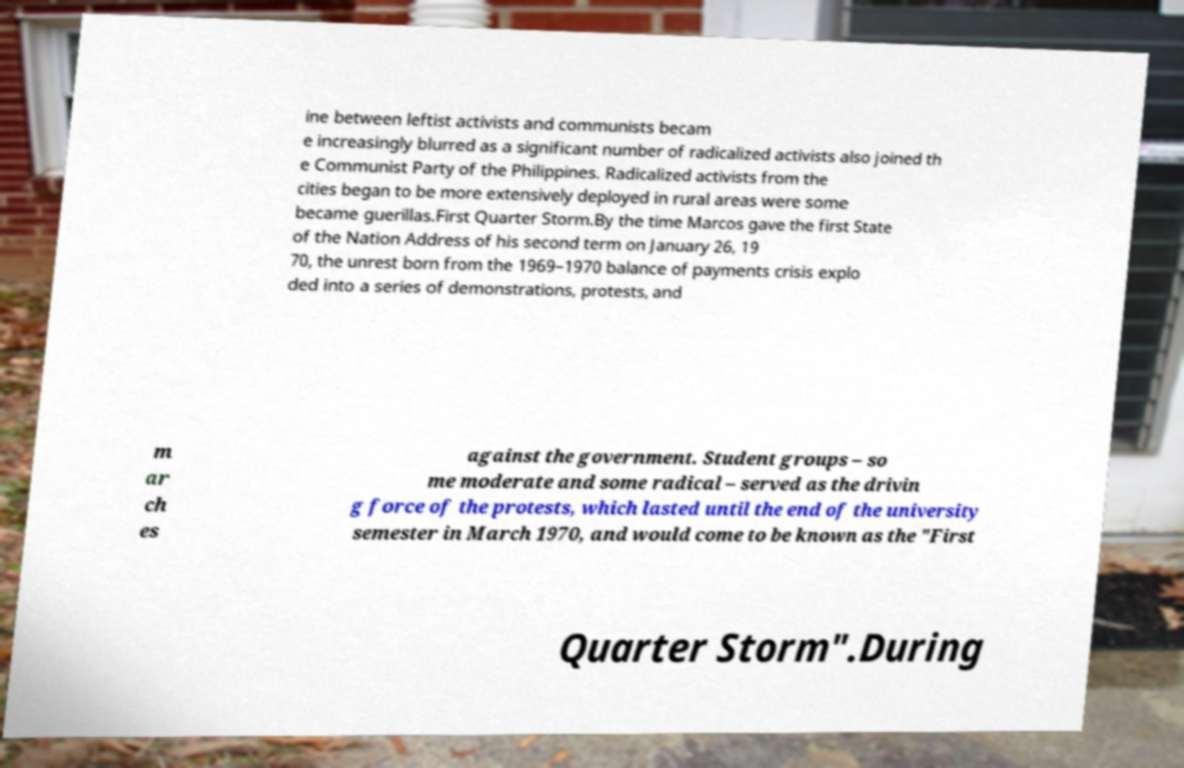Please identify and transcribe the text found in this image. ine between leftist activists and communists becam e increasingly blurred as a significant number of radicalized activists also joined th e Communist Party of the Philippines. Radicalized activists from the cities began to be more extensively deployed in rural areas were some became guerillas.First Quarter Storm.By the time Marcos gave the first State of the Nation Address of his second term on January 26, 19 70, the unrest born from the 1969–1970 balance of payments crisis explo ded into a series of demonstrations, protests, and m ar ch es against the government. Student groups – so me moderate and some radical – served as the drivin g force of the protests, which lasted until the end of the university semester in March 1970, and would come to be known as the "First Quarter Storm".During 